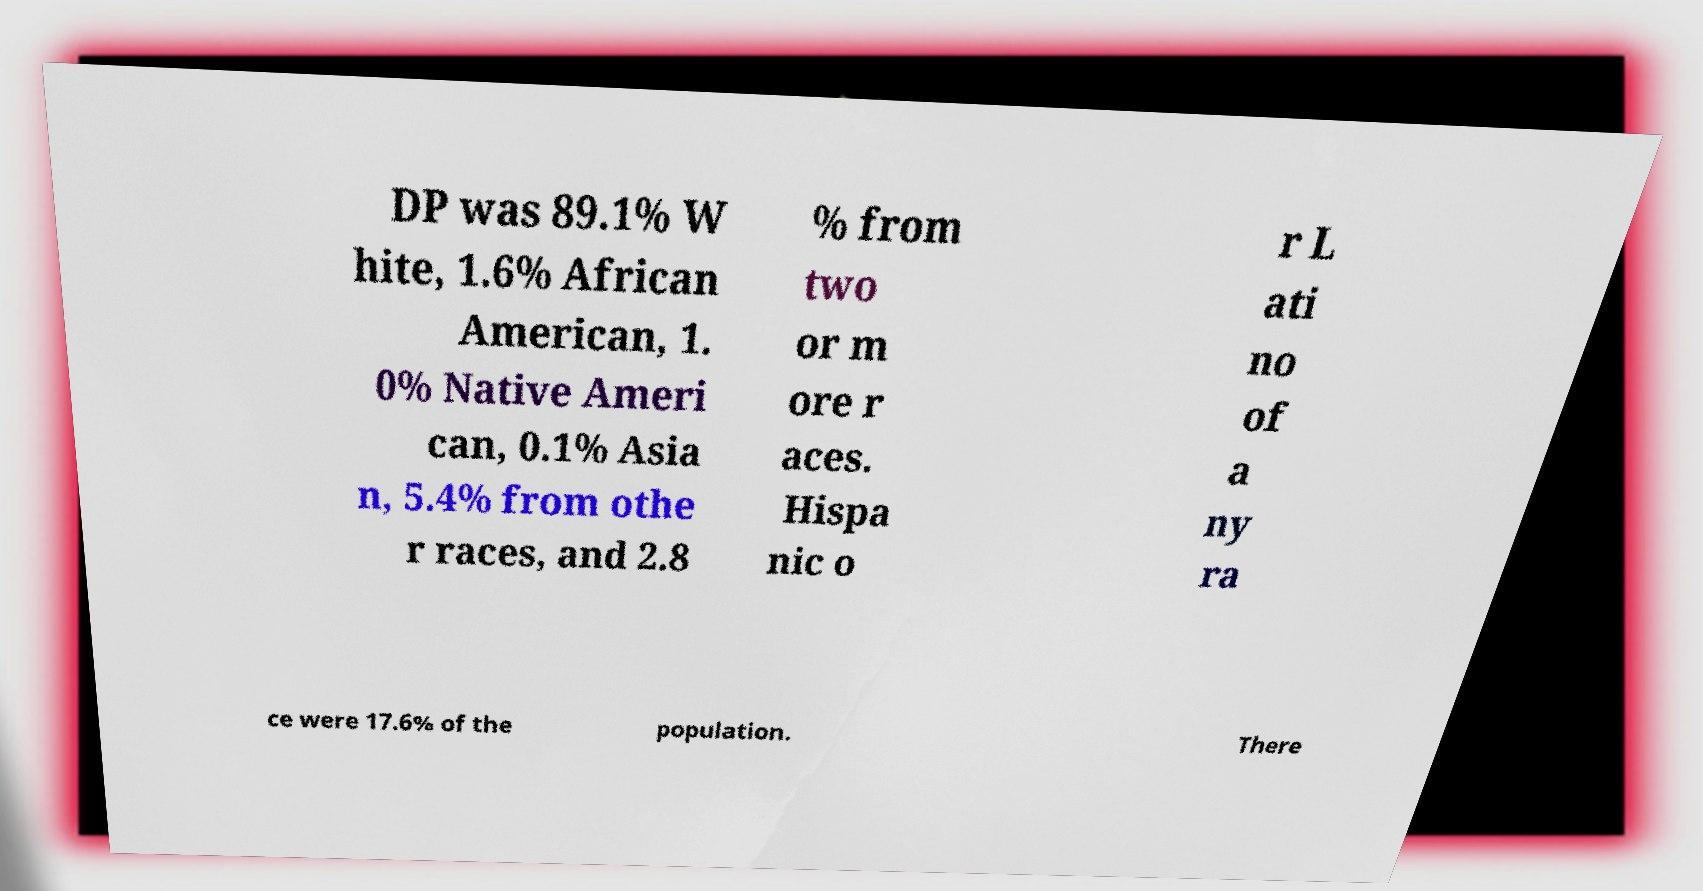Can you read and provide the text displayed in the image?This photo seems to have some interesting text. Can you extract and type it out for me? DP was 89.1% W hite, 1.6% African American, 1. 0% Native Ameri can, 0.1% Asia n, 5.4% from othe r races, and 2.8 % from two or m ore r aces. Hispa nic o r L ati no of a ny ra ce were 17.6% of the population. There 